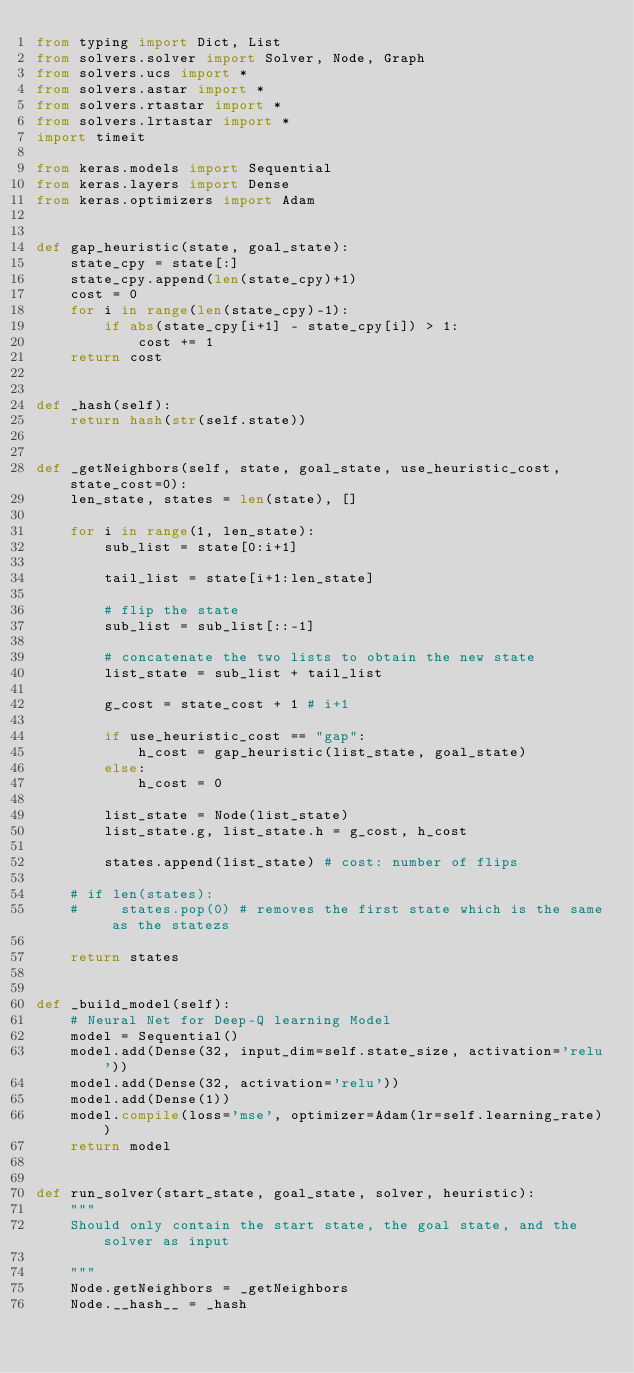<code> <loc_0><loc_0><loc_500><loc_500><_Python_>from typing import Dict, List
from solvers.solver import Solver, Node, Graph
from solvers.ucs import *
from solvers.astar import *
from solvers.rtastar import *
from solvers.lrtastar import *
import timeit

from keras.models import Sequential
from keras.layers import Dense
from keras.optimizers import Adam


def gap_heuristic(state, goal_state):
    state_cpy = state[:]
    state_cpy.append(len(state_cpy)+1)
    cost = 0
    for i in range(len(state_cpy)-1):
        if abs(state_cpy[i+1] - state_cpy[i]) > 1:
            cost += 1
    return cost


def _hash(self):
    return hash(str(self.state))


def _getNeighbors(self, state, goal_state, use_heuristic_cost, state_cost=0):
    len_state, states = len(state), []

    for i in range(1, len_state):
        sub_list = state[0:i+1]

        tail_list = state[i+1:len_state]

        # flip the state
        sub_list = sub_list[::-1]

        # concatenate the two lists to obtain the new state
        list_state = sub_list + tail_list

        g_cost = state_cost + 1 # i+1
        
        if use_heuristic_cost == "gap":
            h_cost = gap_heuristic(list_state, goal_state)
        else:
            h_cost = 0

        list_state = Node(list_state)
        list_state.g, list_state.h = g_cost, h_cost

        states.append(list_state) # cost: number of flips

    # if len(states):
    #     states.pop(0) # removes the first state which is the same as the statezs

    return states


def _build_model(self):
    # Neural Net for Deep-Q learning Model
    model = Sequential()
    model.add(Dense(32, input_dim=self.state_size, activation='relu'))
    model.add(Dense(32, activation='relu'))
    model.add(Dense(1))
    model.compile(loss='mse', optimizer=Adam(lr=self.learning_rate))
    return model


def run_solver(start_state, goal_state, solver, heuristic):
    """
    Should only contain the start state, the goal state, and the solver as input
    
    """
    Node.getNeighbors = _getNeighbors
    Node.__hash__ = _hash
</code> 